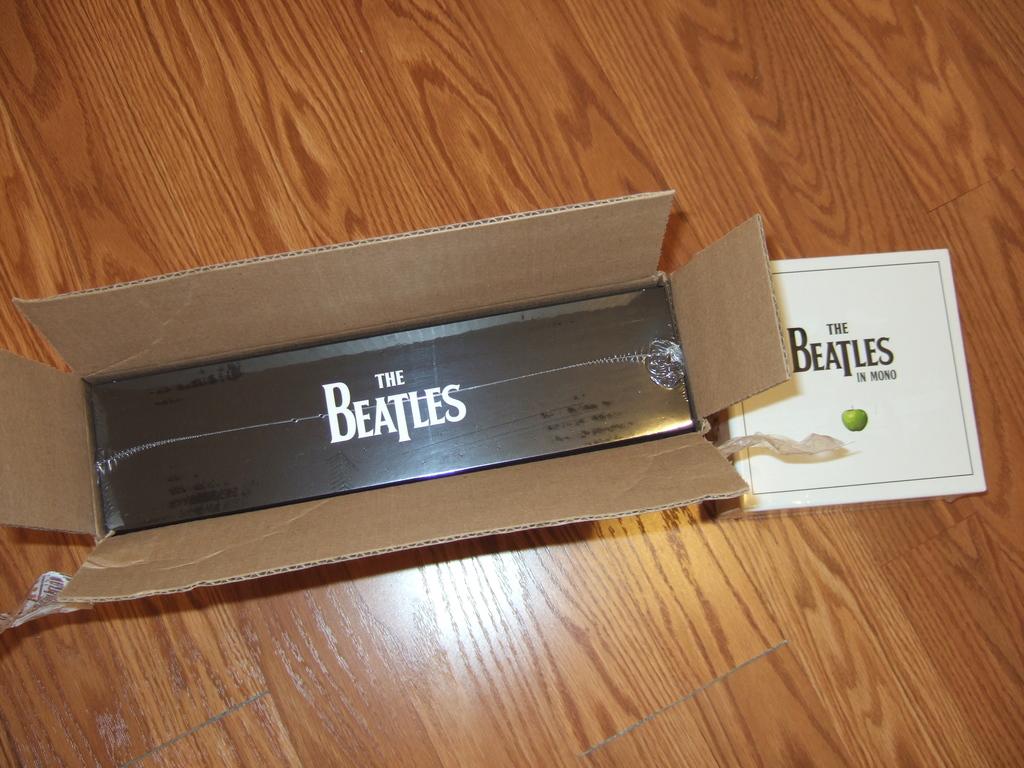What band is in the box?
Make the answer very short. The beatles. What´s in the box?
Your response must be concise. The beatles. 